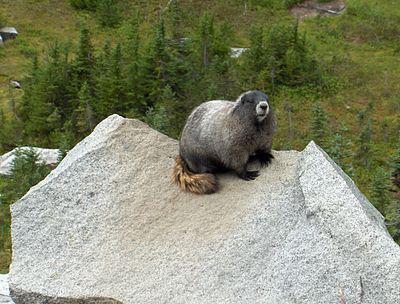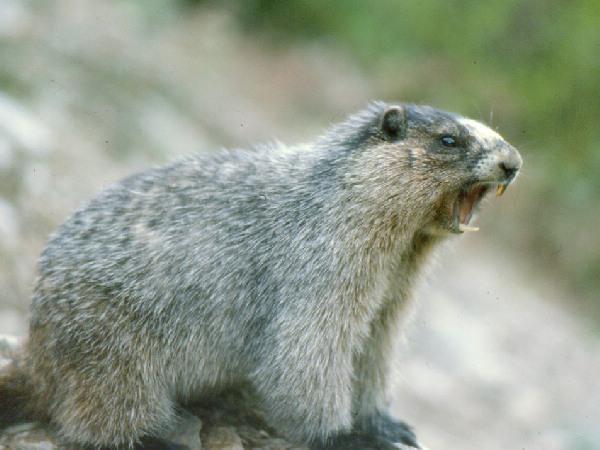The first image is the image on the left, the second image is the image on the right. Evaluate the accuracy of this statement regarding the images: "The left and right image contains the same number of groundhogs on stone..". Is it true? Answer yes or no. Yes. The first image is the image on the left, the second image is the image on the right. For the images shown, is this caption "There are two marmots on rocks." true? Answer yes or no. Yes. 